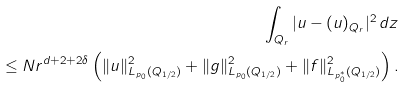<formula> <loc_0><loc_0><loc_500><loc_500>\int _ { Q _ { r } } | u - ( u ) _ { Q _ { r } } | ^ { 2 } \, d z \\ \leq N r ^ { d + 2 + 2 \delta } \left ( \| u \| ^ { 2 } _ { L _ { p _ { 0 } } ( Q _ { 1 / 2 } ) } + \| g \| ^ { 2 } _ { L _ { p _ { 0 } } ( Q _ { 1 / 2 } ) } + \| f \| ^ { 2 } _ { L _ { p ^ { * } _ { 0 } } ( Q _ { 1 / 2 } ) } \right ) .</formula> 